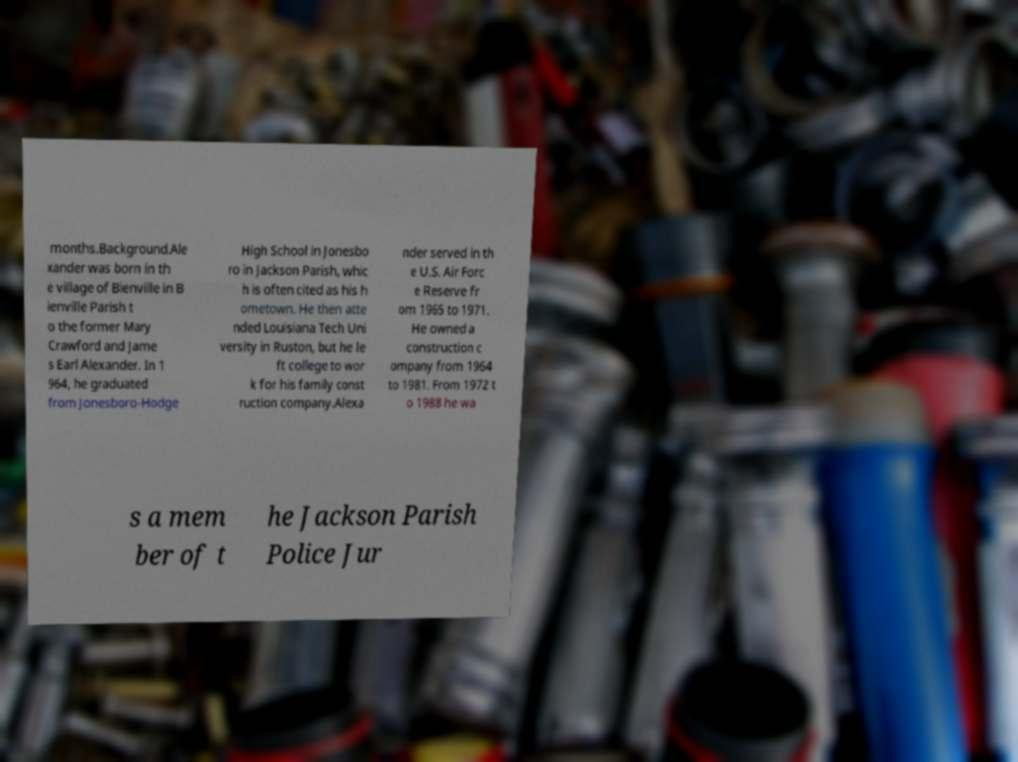Please read and relay the text visible in this image. What does it say? months.Background.Ale xander was born in th e village of Bienville in B ienville Parish t o the former Mary Crawford and Jame s Earl Alexander. In 1 964, he graduated from Jonesboro-Hodge High School in Jonesbo ro in Jackson Parish, whic h is often cited as his h ometown. He then atte nded Louisiana Tech Uni versity in Ruston, but he le ft college to wor k for his family const ruction company.Alexa nder served in th e U.S. Air Forc e Reserve fr om 1965 to 1971. He owned a construction c ompany from 1964 to 1981. From 1972 t o 1988 he wa s a mem ber of t he Jackson Parish Police Jur 